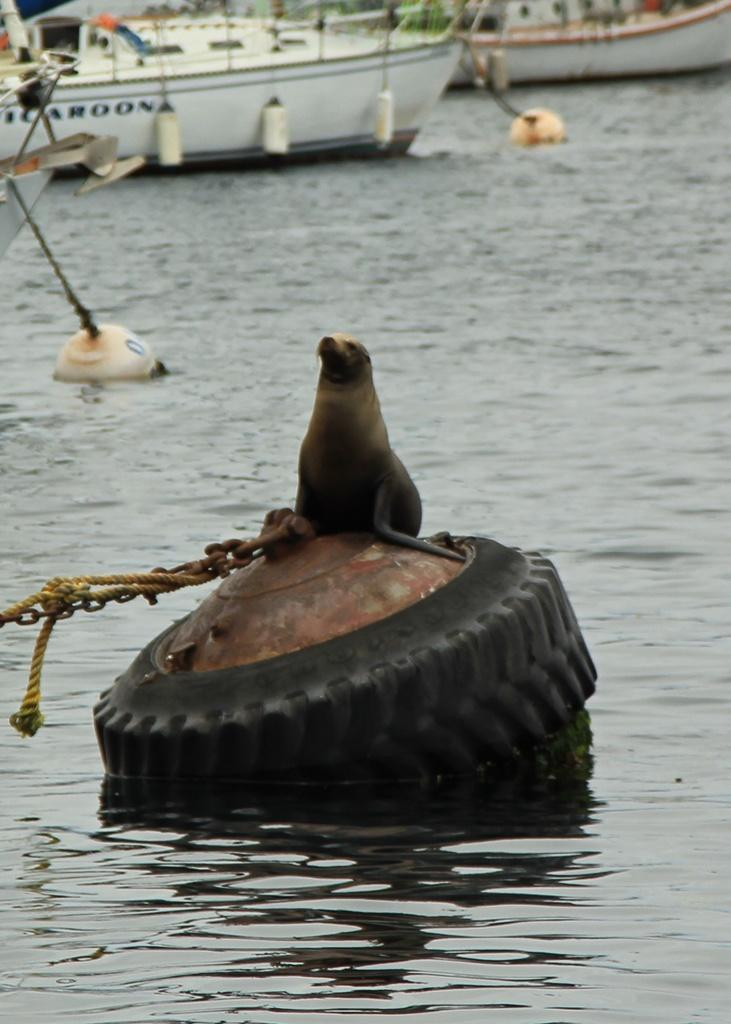What is the main subject of the image? There is a seal on a tyre in the center of the image. What can be seen in the background of the image? There are boats in the background of the image. What is the surrounding environment like in the image? There is water visible in the image. Where is the ant located in the image? There is no ant present in the image. What type of currency exchange is taking place in the image? There is no currency exchange taking place in the image. 